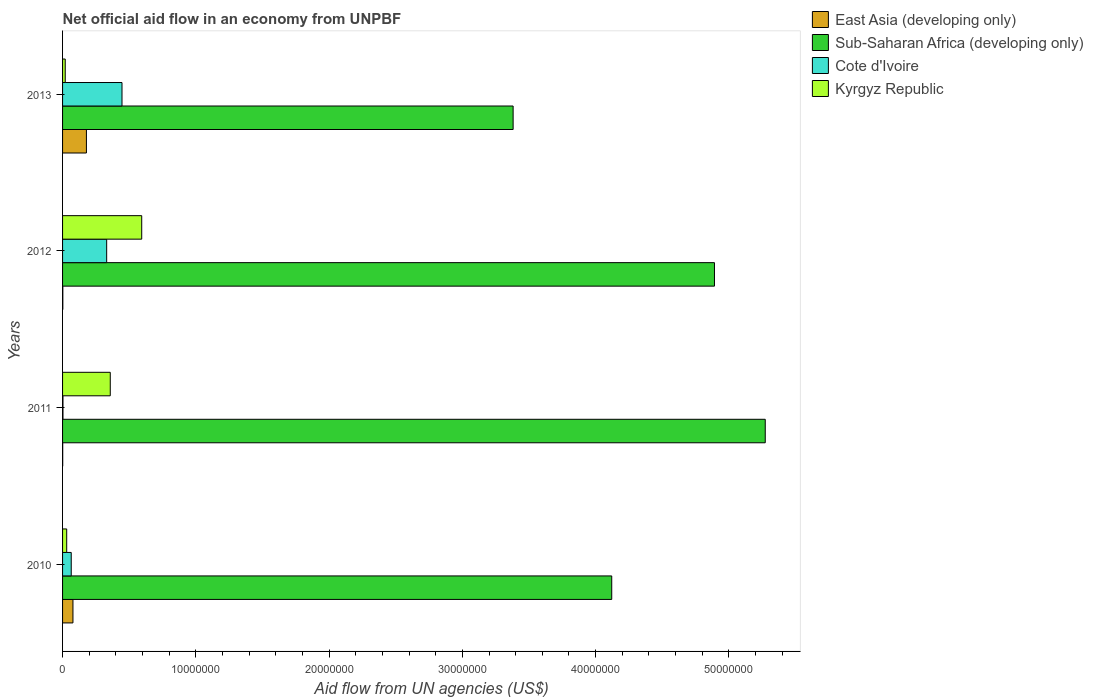How many groups of bars are there?
Offer a very short reply. 4. Are the number of bars on each tick of the Y-axis equal?
Offer a terse response. Yes. How many bars are there on the 3rd tick from the top?
Keep it short and to the point. 4. How many bars are there on the 2nd tick from the bottom?
Your answer should be compact. 4. What is the label of the 2nd group of bars from the top?
Your answer should be compact. 2012. What is the net official aid flow in East Asia (developing only) in 2010?
Offer a very short reply. 7.80e+05. Across all years, what is the maximum net official aid flow in East Asia (developing only)?
Offer a very short reply. 1.79e+06. Across all years, what is the minimum net official aid flow in Cote d'Ivoire?
Provide a short and direct response. 3.00e+04. In which year was the net official aid flow in East Asia (developing only) maximum?
Offer a very short reply. 2013. In which year was the net official aid flow in Kyrgyz Republic minimum?
Your response must be concise. 2013. What is the total net official aid flow in Sub-Saharan Africa (developing only) in the graph?
Your response must be concise. 1.77e+08. What is the difference between the net official aid flow in Sub-Saharan Africa (developing only) in 2011 and that in 2012?
Your answer should be very brief. 3.81e+06. What is the difference between the net official aid flow in Cote d'Ivoire in 2011 and the net official aid flow in Sub-Saharan Africa (developing only) in 2013?
Provide a short and direct response. -3.38e+07. What is the average net official aid flow in Kyrgyz Republic per year?
Offer a very short reply. 2.51e+06. In the year 2011, what is the difference between the net official aid flow in East Asia (developing only) and net official aid flow in Cote d'Ivoire?
Your response must be concise. -2.00e+04. What is the ratio of the net official aid flow in Kyrgyz Republic in 2012 to that in 2013?
Your answer should be very brief. 29.7. Is the difference between the net official aid flow in East Asia (developing only) in 2011 and 2013 greater than the difference between the net official aid flow in Cote d'Ivoire in 2011 and 2013?
Offer a very short reply. Yes. What is the difference between the highest and the second highest net official aid flow in Sub-Saharan Africa (developing only)?
Ensure brevity in your answer.  3.81e+06. What is the difference between the highest and the lowest net official aid flow in Kyrgyz Republic?
Provide a short and direct response. 5.74e+06. Is the sum of the net official aid flow in Sub-Saharan Africa (developing only) in 2012 and 2013 greater than the maximum net official aid flow in East Asia (developing only) across all years?
Your answer should be very brief. Yes. Is it the case that in every year, the sum of the net official aid flow in Kyrgyz Republic and net official aid flow in Cote d'Ivoire is greater than the sum of net official aid flow in Sub-Saharan Africa (developing only) and net official aid flow in East Asia (developing only)?
Offer a very short reply. No. What does the 1st bar from the top in 2012 represents?
Your response must be concise. Kyrgyz Republic. What does the 1st bar from the bottom in 2012 represents?
Make the answer very short. East Asia (developing only). How many bars are there?
Make the answer very short. 16. How many years are there in the graph?
Offer a terse response. 4. Are the values on the major ticks of X-axis written in scientific E-notation?
Your answer should be very brief. No. Does the graph contain any zero values?
Provide a short and direct response. No. Where does the legend appear in the graph?
Make the answer very short. Top right. How are the legend labels stacked?
Offer a terse response. Vertical. What is the title of the graph?
Provide a succinct answer. Net official aid flow in an economy from UNPBF. Does "Aruba" appear as one of the legend labels in the graph?
Provide a short and direct response. No. What is the label or title of the X-axis?
Ensure brevity in your answer.  Aid flow from UN agencies (US$). What is the Aid flow from UN agencies (US$) in East Asia (developing only) in 2010?
Ensure brevity in your answer.  7.80e+05. What is the Aid flow from UN agencies (US$) of Sub-Saharan Africa (developing only) in 2010?
Provide a succinct answer. 4.12e+07. What is the Aid flow from UN agencies (US$) in Cote d'Ivoire in 2010?
Your response must be concise. 6.50e+05. What is the Aid flow from UN agencies (US$) of Kyrgyz Republic in 2010?
Your response must be concise. 3.10e+05. What is the Aid flow from UN agencies (US$) of Sub-Saharan Africa (developing only) in 2011?
Your answer should be very brief. 5.27e+07. What is the Aid flow from UN agencies (US$) of Kyrgyz Republic in 2011?
Give a very brief answer. 3.58e+06. What is the Aid flow from UN agencies (US$) in East Asia (developing only) in 2012?
Ensure brevity in your answer.  2.00e+04. What is the Aid flow from UN agencies (US$) of Sub-Saharan Africa (developing only) in 2012?
Make the answer very short. 4.89e+07. What is the Aid flow from UN agencies (US$) in Cote d'Ivoire in 2012?
Keep it short and to the point. 3.31e+06. What is the Aid flow from UN agencies (US$) of Kyrgyz Republic in 2012?
Make the answer very short. 5.94e+06. What is the Aid flow from UN agencies (US$) of East Asia (developing only) in 2013?
Ensure brevity in your answer.  1.79e+06. What is the Aid flow from UN agencies (US$) in Sub-Saharan Africa (developing only) in 2013?
Give a very brief answer. 3.38e+07. What is the Aid flow from UN agencies (US$) in Cote d'Ivoire in 2013?
Give a very brief answer. 4.46e+06. Across all years, what is the maximum Aid flow from UN agencies (US$) of East Asia (developing only)?
Ensure brevity in your answer.  1.79e+06. Across all years, what is the maximum Aid flow from UN agencies (US$) of Sub-Saharan Africa (developing only)?
Give a very brief answer. 5.27e+07. Across all years, what is the maximum Aid flow from UN agencies (US$) in Cote d'Ivoire?
Your response must be concise. 4.46e+06. Across all years, what is the maximum Aid flow from UN agencies (US$) of Kyrgyz Republic?
Offer a terse response. 5.94e+06. Across all years, what is the minimum Aid flow from UN agencies (US$) of East Asia (developing only)?
Offer a very short reply. 10000. Across all years, what is the minimum Aid flow from UN agencies (US$) of Sub-Saharan Africa (developing only)?
Your response must be concise. 3.38e+07. Across all years, what is the minimum Aid flow from UN agencies (US$) of Kyrgyz Republic?
Make the answer very short. 2.00e+05. What is the total Aid flow from UN agencies (US$) in East Asia (developing only) in the graph?
Provide a succinct answer. 2.60e+06. What is the total Aid flow from UN agencies (US$) in Sub-Saharan Africa (developing only) in the graph?
Your response must be concise. 1.77e+08. What is the total Aid flow from UN agencies (US$) of Cote d'Ivoire in the graph?
Make the answer very short. 8.45e+06. What is the total Aid flow from UN agencies (US$) of Kyrgyz Republic in the graph?
Give a very brief answer. 1.00e+07. What is the difference between the Aid flow from UN agencies (US$) in East Asia (developing only) in 2010 and that in 2011?
Keep it short and to the point. 7.70e+05. What is the difference between the Aid flow from UN agencies (US$) of Sub-Saharan Africa (developing only) in 2010 and that in 2011?
Make the answer very short. -1.15e+07. What is the difference between the Aid flow from UN agencies (US$) in Cote d'Ivoire in 2010 and that in 2011?
Your response must be concise. 6.20e+05. What is the difference between the Aid flow from UN agencies (US$) of Kyrgyz Republic in 2010 and that in 2011?
Ensure brevity in your answer.  -3.27e+06. What is the difference between the Aid flow from UN agencies (US$) of East Asia (developing only) in 2010 and that in 2012?
Give a very brief answer. 7.60e+05. What is the difference between the Aid flow from UN agencies (US$) of Sub-Saharan Africa (developing only) in 2010 and that in 2012?
Give a very brief answer. -7.71e+06. What is the difference between the Aid flow from UN agencies (US$) of Cote d'Ivoire in 2010 and that in 2012?
Make the answer very short. -2.66e+06. What is the difference between the Aid flow from UN agencies (US$) of Kyrgyz Republic in 2010 and that in 2012?
Offer a very short reply. -5.63e+06. What is the difference between the Aid flow from UN agencies (US$) of East Asia (developing only) in 2010 and that in 2013?
Offer a terse response. -1.01e+06. What is the difference between the Aid flow from UN agencies (US$) in Sub-Saharan Africa (developing only) in 2010 and that in 2013?
Offer a terse response. 7.40e+06. What is the difference between the Aid flow from UN agencies (US$) of Cote d'Ivoire in 2010 and that in 2013?
Offer a very short reply. -3.81e+06. What is the difference between the Aid flow from UN agencies (US$) of East Asia (developing only) in 2011 and that in 2012?
Provide a short and direct response. -10000. What is the difference between the Aid flow from UN agencies (US$) in Sub-Saharan Africa (developing only) in 2011 and that in 2012?
Your answer should be compact. 3.81e+06. What is the difference between the Aid flow from UN agencies (US$) of Cote d'Ivoire in 2011 and that in 2012?
Your answer should be very brief. -3.28e+06. What is the difference between the Aid flow from UN agencies (US$) of Kyrgyz Republic in 2011 and that in 2012?
Your answer should be compact. -2.36e+06. What is the difference between the Aid flow from UN agencies (US$) of East Asia (developing only) in 2011 and that in 2013?
Ensure brevity in your answer.  -1.78e+06. What is the difference between the Aid flow from UN agencies (US$) of Sub-Saharan Africa (developing only) in 2011 and that in 2013?
Your answer should be compact. 1.89e+07. What is the difference between the Aid flow from UN agencies (US$) in Cote d'Ivoire in 2011 and that in 2013?
Provide a succinct answer. -4.43e+06. What is the difference between the Aid flow from UN agencies (US$) of Kyrgyz Republic in 2011 and that in 2013?
Ensure brevity in your answer.  3.38e+06. What is the difference between the Aid flow from UN agencies (US$) in East Asia (developing only) in 2012 and that in 2013?
Offer a very short reply. -1.77e+06. What is the difference between the Aid flow from UN agencies (US$) in Sub-Saharan Africa (developing only) in 2012 and that in 2013?
Your response must be concise. 1.51e+07. What is the difference between the Aid flow from UN agencies (US$) of Cote d'Ivoire in 2012 and that in 2013?
Give a very brief answer. -1.15e+06. What is the difference between the Aid flow from UN agencies (US$) in Kyrgyz Republic in 2012 and that in 2013?
Your answer should be compact. 5.74e+06. What is the difference between the Aid flow from UN agencies (US$) in East Asia (developing only) in 2010 and the Aid flow from UN agencies (US$) in Sub-Saharan Africa (developing only) in 2011?
Your answer should be very brief. -5.20e+07. What is the difference between the Aid flow from UN agencies (US$) in East Asia (developing only) in 2010 and the Aid flow from UN agencies (US$) in Cote d'Ivoire in 2011?
Provide a short and direct response. 7.50e+05. What is the difference between the Aid flow from UN agencies (US$) in East Asia (developing only) in 2010 and the Aid flow from UN agencies (US$) in Kyrgyz Republic in 2011?
Provide a succinct answer. -2.80e+06. What is the difference between the Aid flow from UN agencies (US$) in Sub-Saharan Africa (developing only) in 2010 and the Aid flow from UN agencies (US$) in Cote d'Ivoire in 2011?
Ensure brevity in your answer.  4.12e+07. What is the difference between the Aid flow from UN agencies (US$) in Sub-Saharan Africa (developing only) in 2010 and the Aid flow from UN agencies (US$) in Kyrgyz Republic in 2011?
Provide a short and direct response. 3.76e+07. What is the difference between the Aid flow from UN agencies (US$) in Cote d'Ivoire in 2010 and the Aid flow from UN agencies (US$) in Kyrgyz Republic in 2011?
Offer a terse response. -2.93e+06. What is the difference between the Aid flow from UN agencies (US$) of East Asia (developing only) in 2010 and the Aid flow from UN agencies (US$) of Sub-Saharan Africa (developing only) in 2012?
Your answer should be very brief. -4.81e+07. What is the difference between the Aid flow from UN agencies (US$) of East Asia (developing only) in 2010 and the Aid flow from UN agencies (US$) of Cote d'Ivoire in 2012?
Keep it short and to the point. -2.53e+06. What is the difference between the Aid flow from UN agencies (US$) of East Asia (developing only) in 2010 and the Aid flow from UN agencies (US$) of Kyrgyz Republic in 2012?
Make the answer very short. -5.16e+06. What is the difference between the Aid flow from UN agencies (US$) in Sub-Saharan Africa (developing only) in 2010 and the Aid flow from UN agencies (US$) in Cote d'Ivoire in 2012?
Offer a very short reply. 3.79e+07. What is the difference between the Aid flow from UN agencies (US$) of Sub-Saharan Africa (developing only) in 2010 and the Aid flow from UN agencies (US$) of Kyrgyz Republic in 2012?
Keep it short and to the point. 3.53e+07. What is the difference between the Aid flow from UN agencies (US$) in Cote d'Ivoire in 2010 and the Aid flow from UN agencies (US$) in Kyrgyz Republic in 2012?
Give a very brief answer. -5.29e+06. What is the difference between the Aid flow from UN agencies (US$) of East Asia (developing only) in 2010 and the Aid flow from UN agencies (US$) of Sub-Saharan Africa (developing only) in 2013?
Offer a very short reply. -3.30e+07. What is the difference between the Aid flow from UN agencies (US$) in East Asia (developing only) in 2010 and the Aid flow from UN agencies (US$) in Cote d'Ivoire in 2013?
Ensure brevity in your answer.  -3.68e+06. What is the difference between the Aid flow from UN agencies (US$) in East Asia (developing only) in 2010 and the Aid flow from UN agencies (US$) in Kyrgyz Republic in 2013?
Keep it short and to the point. 5.80e+05. What is the difference between the Aid flow from UN agencies (US$) in Sub-Saharan Africa (developing only) in 2010 and the Aid flow from UN agencies (US$) in Cote d'Ivoire in 2013?
Provide a short and direct response. 3.68e+07. What is the difference between the Aid flow from UN agencies (US$) in Sub-Saharan Africa (developing only) in 2010 and the Aid flow from UN agencies (US$) in Kyrgyz Republic in 2013?
Your answer should be very brief. 4.10e+07. What is the difference between the Aid flow from UN agencies (US$) of Cote d'Ivoire in 2010 and the Aid flow from UN agencies (US$) of Kyrgyz Republic in 2013?
Your answer should be very brief. 4.50e+05. What is the difference between the Aid flow from UN agencies (US$) of East Asia (developing only) in 2011 and the Aid flow from UN agencies (US$) of Sub-Saharan Africa (developing only) in 2012?
Ensure brevity in your answer.  -4.89e+07. What is the difference between the Aid flow from UN agencies (US$) in East Asia (developing only) in 2011 and the Aid flow from UN agencies (US$) in Cote d'Ivoire in 2012?
Make the answer very short. -3.30e+06. What is the difference between the Aid flow from UN agencies (US$) of East Asia (developing only) in 2011 and the Aid flow from UN agencies (US$) of Kyrgyz Republic in 2012?
Your response must be concise. -5.93e+06. What is the difference between the Aid flow from UN agencies (US$) in Sub-Saharan Africa (developing only) in 2011 and the Aid flow from UN agencies (US$) in Cote d'Ivoire in 2012?
Your answer should be compact. 4.94e+07. What is the difference between the Aid flow from UN agencies (US$) in Sub-Saharan Africa (developing only) in 2011 and the Aid flow from UN agencies (US$) in Kyrgyz Republic in 2012?
Your answer should be very brief. 4.68e+07. What is the difference between the Aid flow from UN agencies (US$) in Cote d'Ivoire in 2011 and the Aid flow from UN agencies (US$) in Kyrgyz Republic in 2012?
Ensure brevity in your answer.  -5.91e+06. What is the difference between the Aid flow from UN agencies (US$) in East Asia (developing only) in 2011 and the Aid flow from UN agencies (US$) in Sub-Saharan Africa (developing only) in 2013?
Offer a terse response. -3.38e+07. What is the difference between the Aid flow from UN agencies (US$) of East Asia (developing only) in 2011 and the Aid flow from UN agencies (US$) of Cote d'Ivoire in 2013?
Your answer should be compact. -4.45e+06. What is the difference between the Aid flow from UN agencies (US$) of East Asia (developing only) in 2011 and the Aid flow from UN agencies (US$) of Kyrgyz Republic in 2013?
Provide a succinct answer. -1.90e+05. What is the difference between the Aid flow from UN agencies (US$) of Sub-Saharan Africa (developing only) in 2011 and the Aid flow from UN agencies (US$) of Cote d'Ivoire in 2013?
Your response must be concise. 4.83e+07. What is the difference between the Aid flow from UN agencies (US$) of Sub-Saharan Africa (developing only) in 2011 and the Aid flow from UN agencies (US$) of Kyrgyz Republic in 2013?
Offer a very short reply. 5.25e+07. What is the difference between the Aid flow from UN agencies (US$) of Cote d'Ivoire in 2011 and the Aid flow from UN agencies (US$) of Kyrgyz Republic in 2013?
Your answer should be compact. -1.70e+05. What is the difference between the Aid flow from UN agencies (US$) in East Asia (developing only) in 2012 and the Aid flow from UN agencies (US$) in Sub-Saharan Africa (developing only) in 2013?
Give a very brief answer. -3.38e+07. What is the difference between the Aid flow from UN agencies (US$) in East Asia (developing only) in 2012 and the Aid flow from UN agencies (US$) in Cote d'Ivoire in 2013?
Make the answer very short. -4.44e+06. What is the difference between the Aid flow from UN agencies (US$) in Sub-Saharan Africa (developing only) in 2012 and the Aid flow from UN agencies (US$) in Cote d'Ivoire in 2013?
Give a very brief answer. 4.45e+07. What is the difference between the Aid flow from UN agencies (US$) in Sub-Saharan Africa (developing only) in 2012 and the Aid flow from UN agencies (US$) in Kyrgyz Republic in 2013?
Ensure brevity in your answer.  4.87e+07. What is the difference between the Aid flow from UN agencies (US$) in Cote d'Ivoire in 2012 and the Aid flow from UN agencies (US$) in Kyrgyz Republic in 2013?
Your response must be concise. 3.11e+06. What is the average Aid flow from UN agencies (US$) of East Asia (developing only) per year?
Your answer should be very brief. 6.50e+05. What is the average Aid flow from UN agencies (US$) in Sub-Saharan Africa (developing only) per year?
Offer a very short reply. 4.42e+07. What is the average Aid flow from UN agencies (US$) in Cote d'Ivoire per year?
Keep it short and to the point. 2.11e+06. What is the average Aid flow from UN agencies (US$) in Kyrgyz Republic per year?
Offer a very short reply. 2.51e+06. In the year 2010, what is the difference between the Aid flow from UN agencies (US$) in East Asia (developing only) and Aid flow from UN agencies (US$) in Sub-Saharan Africa (developing only)?
Provide a short and direct response. -4.04e+07. In the year 2010, what is the difference between the Aid flow from UN agencies (US$) in East Asia (developing only) and Aid flow from UN agencies (US$) in Cote d'Ivoire?
Provide a succinct answer. 1.30e+05. In the year 2010, what is the difference between the Aid flow from UN agencies (US$) in Sub-Saharan Africa (developing only) and Aid flow from UN agencies (US$) in Cote d'Ivoire?
Offer a terse response. 4.06e+07. In the year 2010, what is the difference between the Aid flow from UN agencies (US$) in Sub-Saharan Africa (developing only) and Aid flow from UN agencies (US$) in Kyrgyz Republic?
Give a very brief answer. 4.09e+07. In the year 2010, what is the difference between the Aid flow from UN agencies (US$) of Cote d'Ivoire and Aid flow from UN agencies (US$) of Kyrgyz Republic?
Keep it short and to the point. 3.40e+05. In the year 2011, what is the difference between the Aid flow from UN agencies (US$) of East Asia (developing only) and Aid flow from UN agencies (US$) of Sub-Saharan Africa (developing only)?
Your answer should be compact. -5.27e+07. In the year 2011, what is the difference between the Aid flow from UN agencies (US$) of East Asia (developing only) and Aid flow from UN agencies (US$) of Kyrgyz Republic?
Keep it short and to the point. -3.57e+06. In the year 2011, what is the difference between the Aid flow from UN agencies (US$) of Sub-Saharan Africa (developing only) and Aid flow from UN agencies (US$) of Cote d'Ivoire?
Ensure brevity in your answer.  5.27e+07. In the year 2011, what is the difference between the Aid flow from UN agencies (US$) in Sub-Saharan Africa (developing only) and Aid flow from UN agencies (US$) in Kyrgyz Republic?
Your answer should be compact. 4.92e+07. In the year 2011, what is the difference between the Aid flow from UN agencies (US$) in Cote d'Ivoire and Aid flow from UN agencies (US$) in Kyrgyz Republic?
Keep it short and to the point. -3.55e+06. In the year 2012, what is the difference between the Aid flow from UN agencies (US$) in East Asia (developing only) and Aid flow from UN agencies (US$) in Sub-Saharan Africa (developing only)?
Provide a short and direct response. -4.89e+07. In the year 2012, what is the difference between the Aid flow from UN agencies (US$) of East Asia (developing only) and Aid flow from UN agencies (US$) of Cote d'Ivoire?
Give a very brief answer. -3.29e+06. In the year 2012, what is the difference between the Aid flow from UN agencies (US$) of East Asia (developing only) and Aid flow from UN agencies (US$) of Kyrgyz Republic?
Make the answer very short. -5.92e+06. In the year 2012, what is the difference between the Aid flow from UN agencies (US$) of Sub-Saharan Africa (developing only) and Aid flow from UN agencies (US$) of Cote d'Ivoire?
Your answer should be compact. 4.56e+07. In the year 2012, what is the difference between the Aid flow from UN agencies (US$) in Sub-Saharan Africa (developing only) and Aid flow from UN agencies (US$) in Kyrgyz Republic?
Make the answer very short. 4.30e+07. In the year 2012, what is the difference between the Aid flow from UN agencies (US$) of Cote d'Ivoire and Aid flow from UN agencies (US$) of Kyrgyz Republic?
Offer a terse response. -2.63e+06. In the year 2013, what is the difference between the Aid flow from UN agencies (US$) in East Asia (developing only) and Aid flow from UN agencies (US$) in Sub-Saharan Africa (developing only)?
Your answer should be compact. -3.20e+07. In the year 2013, what is the difference between the Aid flow from UN agencies (US$) in East Asia (developing only) and Aid flow from UN agencies (US$) in Cote d'Ivoire?
Keep it short and to the point. -2.67e+06. In the year 2013, what is the difference between the Aid flow from UN agencies (US$) of East Asia (developing only) and Aid flow from UN agencies (US$) of Kyrgyz Republic?
Provide a short and direct response. 1.59e+06. In the year 2013, what is the difference between the Aid flow from UN agencies (US$) of Sub-Saharan Africa (developing only) and Aid flow from UN agencies (US$) of Cote d'Ivoire?
Ensure brevity in your answer.  2.94e+07. In the year 2013, what is the difference between the Aid flow from UN agencies (US$) of Sub-Saharan Africa (developing only) and Aid flow from UN agencies (US$) of Kyrgyz Republic?
Provide a succinct answer. 3.36e+07. In the year 2013, what is the difference between the Aid flow from UN agencies (US$) of Cote d'Ivoire and Aid flow from UN agencies (US$) of Kyrgyz Republic?
Your response must be concise. 4.26e+06. What is the ratio of the Aid flow from UN agencies (US$) of Sub-Saharan Africa (developing only) in 2010 to that in 2011?
Give a very brief answer. 0.78. What is the ratio of the Aid flow from UN agencies (US$) in Cote d'Ivoire in 2010 to that in 2011?
Your answer should be compact. 21.67. What is the ratio of the Aid flow from UN agencies (US$) of Kyrgyz Republic in 2010 to that in 2011?
Give a very brief answer. 0.09. What is the ratio of the Aid flow from UN agencies (US$) of East Asia (developing only) in 2010 to that in 2012?
Your answer should be very brief. 39. What is the ratio of the Aid flow from UN agencies (US$) in Sub-Saharan Africa (developing only) in 2010 to that in 2012?
Offer a terse response. 0.84. What is the ratio of the Aid flow from UN agencies (US$) of Cote d'Ivoire in 2010 to that in 2012?
Keep it short and to the point. 0.2. What is the ratio of the Aid flow from UN agencies (US$) in Kyrgyz Republic in 2010 to that in 2012?
Ensure brevity in your answer.  0.05. What is the ratio of the Aid flow from UN agencies (US$) of East Asia (developing only) in 2010 to that in 2013?
Ensure brevity in your answer.  0.44. What is the ratio of the Aid flow from UN agencies (US$) of Sub-Saharan Africa (developing only) in 2010 to that in 2013?
Your response must be concise. 1.22. What is the ratio of the Aid flow from UN agencies (US$) of Cote d'Ivoire in 2010 to that in 2013?
Keep it short and to the point. 0.15. What is the ratio of the Aid flow from UN agencies (US$) of Kyrgyz Republic in 2010 to that in 2013?
Keep it short and to the point. 1.55. What is the ratio of the Aid flow from UN agencies (US$) of East Asia (developing only) in 2011 to that in 2012?
Provide a succinct answer. 0.5. What is the ratio of the Aid flow from UN agencies (US$) in Sub-Saharan Africa (developing only) in 2011 to that in 2012?
Your answer should be compact. 1.08. What is the ratio of the Aid flow from UN agencies (US$) in Cote d'Ivoire in 2011 to that in 2012?
Provide a short and direct response. 0.01. What is the ratio of the Aid flow from UN agencies (US$) of Kyrgyz Republic in 2011 to that in 2012?
Ensure brevity in your answer.  0.6. What is the ratio of the Aid flow from UN agencies (US$) in East Asia (developing only) in 2011 to that in 2013?
Make the answer very short. 0.01. What is the ratio of the Aid flow from UN agencies (US$) in Sub-Saharan Africa (developing only) in 2011 to that in 2013?
Provide a succinct answer. 1.56. What is the ratio of the Aid flow from UN agencies (US$) of Cote d'Ivoire in 2011 to that in 2013?
Your response must be concise. 0.01. What is the ratio of the Aid flow from UN agencies (US$) in East Asia (developing only) in 2012 to that in 2013?
Your response must be concise. 0.01. What is the ratio of the Aid flow from UN agencies (US$) of Sub-Saharan Africa (developing only) in 2012 to that in 2013?
Ensure brevity in your answer.  1.45. What is the ratio of the Aid flow from UN agencies (US$) in Cote d'Ivoire in 2012 to that in 2013?
Your response must be concise. 0.74. What is the ratio of the Aid flow from UN agencies (US$) in Kyrgyz Republic in 2012 to that in 2013?
Make the answer very short. 29.7. What is the difference between the highest and the second highest Aid flow from UN agencies (US$) in East Asia (developing only)?
Make the answer very short. 1.01e+06. What is the difference between the highest and the second highest Aid flow from UN agencies (US$) in Sub-Saharan Africa (developing only)?
Offer a very short reply. 3.81e+06. What is the difference between the highest and the second highest Aid flow from UN agencies (US$) in Cote d'Ivoire?
Provide a succinct answer. 1.15e+06. What is the difference between the highest and the second highest Aid flow from UN agencies (US$) in Kyrgyz Republic?
Give a very brief answer. 2.36e+06. What is the difference between the highest and the lowest Aid flow from UN agencies (US$) in East Asia (developing only)?
Keep it short and to the point. 1.78e+06. What is the difference between the highest and the lowest Aid flow from UN agencies (US$) in Sub-Saharan Africa (developing only)?
Your response must be concise. 1.89e+07. What is the difference between the highest and the lowest Aid flow from UN agencies (US$) in Cote d'Ivoire?
Offer a terse response. 4.43e+06. What is the difference between the highest and the lowest Aid flow from UN agencies (US$) in Kyrgyz Republic?
Keep it short and to the point. 5.74e+06. 